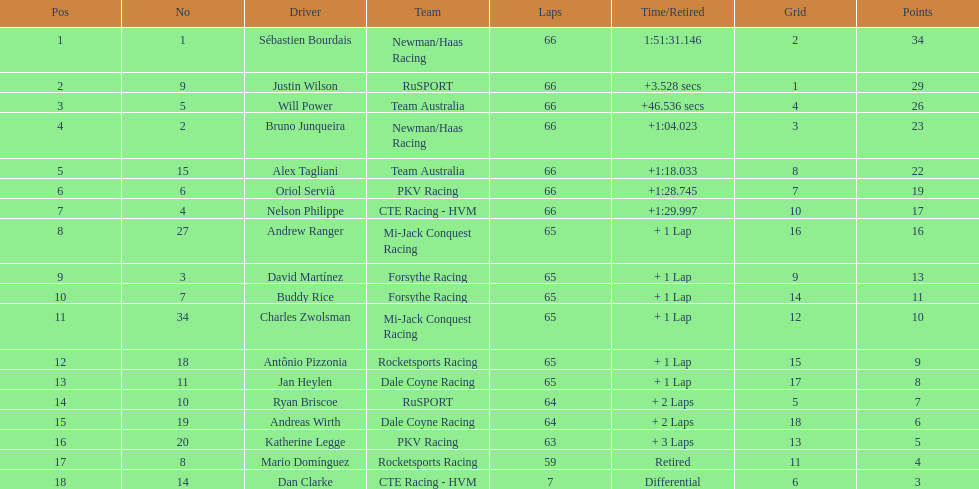At the 2006 gran premio telmex, how many drivers completed less than 60 laps? 2. 